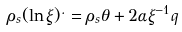Convert formula to latex. <formula><loc_0><loc_0><loc_500><loc_500>\rho _ { s } ( \ln \xi ) ^ { . } = \rho _ { s } \theta + 2 \alpha \xi ^ { - 1 } q</formula> 